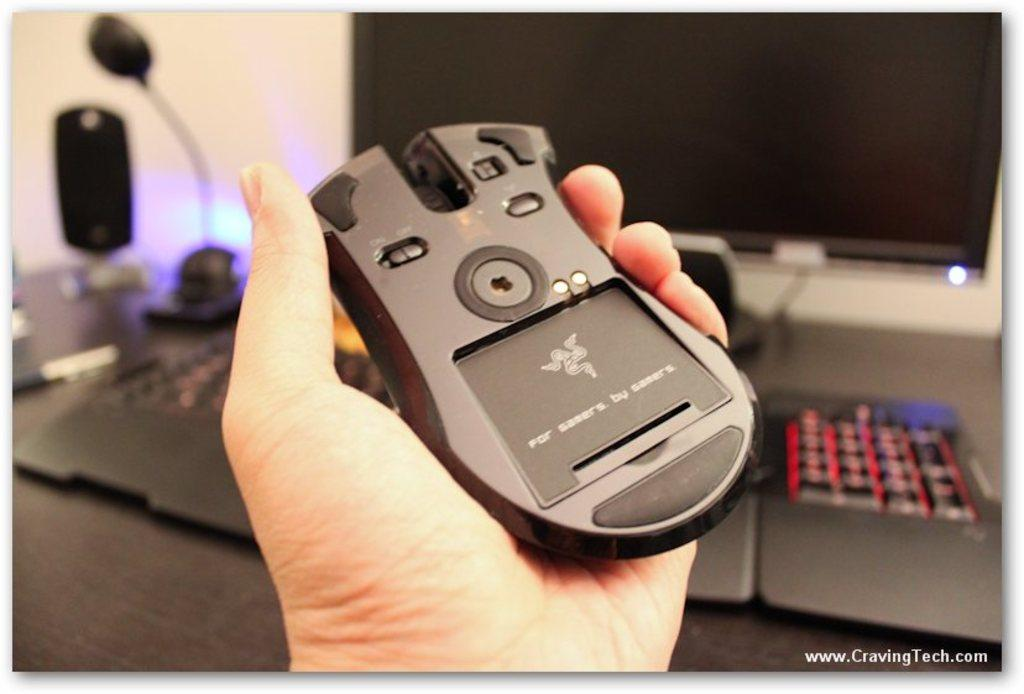What is the main subject in the center of the image? There is a mouse in the center of the image. What is the mouse in? The mouse is in a hand. What objects can be seen in the background of the image? There is a monitor, keyboard, light, speaker, pen, and a wall in the background of the image. What degree does the squirrel have in the image? There is no squirrel present in the image, and therefore no degree can be attributed to it. 